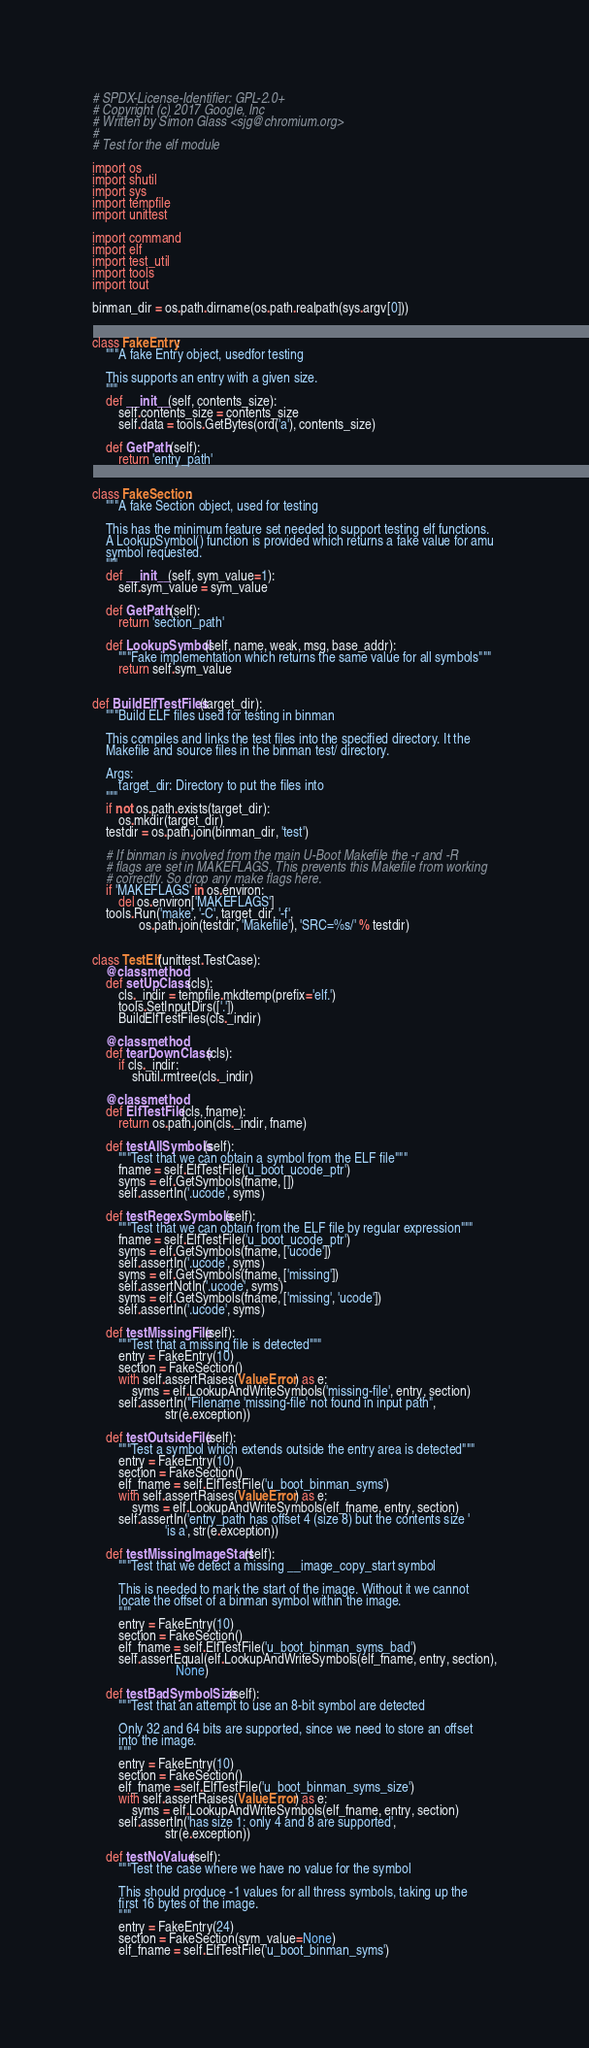Convert code to text. <code><loc_0><loc_0><loc_500><loc_500><_Python_># SPDX-License-Identifier: GPL-2.0+
# Copyright (c) 2017 Google, Inc
# Written by Simon Glass <sjg@chromium.org>
#
# Test for the elf module

import os
import shutil
import sys
import tempfile
import unittest

import command
import elf
import test_util
import tools
import tout

binman_dir = os.path.dirname(os.path.realpath(sys.argv[0]))


class FakeEntry:
    """A fake Entry object, usedfor testing

    This supports an entry with a given size.
    """
    def __init__(self, contents_size):
        self.contents_size = contents_size
        self.data = tools.GetBytes(ord('a'), contents_size)

    def GetPath(self):
        return 'entry_path'


class FakeSection:
    """A fake Section object, used for testing

    This has the minimum feature set needed to support testing elf functions.
    A LookupSymbol() function is provided which returns a fake value for amu
    symbol requested.
    """
    def __init__(self, sym_value=1):
        self.sym_value = sym_value

    def GetPath(self):
        return 'section_path'

    def LookupSymbol(self, name, weak, msg, base_addr):
        """Fake implementation which returns the same value for all symbols"""
        return self.sym_value


def BuildElfTestFiles(target_dir):
    """Build ELF files used for testing in binman

    This compiles and links the test files into the specified directory. It the
    Makefile and source files in the binman test/ directory.

    Args:
        target_dir: Directory to put the files into
    """
    if not os.path.exists(target_dir):
        os.mkdir(target_dir)
    testdir = os.path.join(binman_dir, 'test')

    # If binman is involved from the main U-Boot Makefile the -r and -R
    # flags are set in MAKEFLAGS. This prevents this Makefile from working
    # correctly. So drop any make flags here.
    if 'MAKEFLAGS' in os.environ:
        del os.environ['MAKEFLAGS']
    tools.Run('make', '-C', target_dir, '-f',
              os.path.join(testdir, 'Makefile'), 'SRC=%s/' % testdir)


class TestElf(unittest.TestCase):
    @classmethod
    def setUpClass(cls):
        cls._indir = tempfile.mkdtemp(prefix='elf.')
        tools.SetInputDirs(['.'])
        BuildElfTestFiles(cls._indir)

    @classmethod
    def tearDownClass(cls):
        if cls._indir:
            shutil.rmtree(cls._indir)

    @classmethod
    def ElfTestFile(cls, fname):
        return os.path.join(cls._indir, fname)

    def testAllSymbols(self):
        """Test that we can obtain a symbol from the ELF file"""
        fname = self.ElfTestFile('u_boot_ucode_ptr')
        syms = elf.GetSymbols(fname, [])
        self.assertIn('.ucode', syms)

    def testRegexSymbols(self):
        """Test that we can obtain from the ELF file by regular expression"""
        fname = self.ElfTestFile('u_boot_ucode_ptr')
        syms = elf.GetSymbols(fname, ['ucode'])
        self.assertIn('.ucode', syms)
        syms = elf.GetSymbols(fname, ['missing'])
        self.assertNotIn('.ucode', syms)
        syms = elf.GetSymbols(fname, ['missing', 'ucode'])
        self.assertIn('.ucode', syms)

    def testMissingFile(self):
        """Test that a missing file is detected"""
        entry = FakeEntry(10)
        section = FakeSection()
        with self.assertRaises(ValueError) as e:
            syms = elf.LookupAndWriteSymbols('missing-file', entry, section)
        self.assertIn("Filename 'missing-file' not found in input path",
                      str(e.exception))

    def testOutsideFile(self):
        """Test a symbol which extends outside the entry area is detected"""
        entry = FakeEntry(10)
        section = FakeSection()
        elf_fname = self.ElfTestFile('u_boot_binman_syms')
        with self.assertRaises(ValueError) as e:
            syms = elf.LookupAndWriteSymbols(elf_fname, entry, section)
        self.assertIn('entry_path has offset 4 (size 8) but the contents size '
                      'is a', str(e.exception))

    def testMissingImageStart(self):
        """Test that we detect a missing __image_copy_start symbol

        This is needed to mark the start of the image. Without it we cannot
        locate the offset of a binman symbol within the image.
        """
        entry = FakeEntry(10)
        section = FakeSection()
        elf_fname = self.ElfTestFile('u_boot_binman_syms_bad')
        self.assertEqual(elf.LookupAndWriteSymbols(elf_fname, entry, section),
                         None)

    def testBadSymbolSize(self):
        """Test that an attempt to use an 8-bit symbol are detected

        Only 32 and 64 bits are supported, since we need to store an offset
        into the image.
        """
        entry = FakeEntry(10)
        section = FakeSection()
        elf_fname =self.ElfTestFile('u_boot_binman_syms_size')
        with self.assertRaises(ValueError) as e:
            syms = elf.LookupAndWriteSymbols(elf_fname, entry, section)
        self.assertIn('has size 1: only 4 and 8 are supported',
                      str(e.exception))

    def testNoValue(self):
        """Test the case where we have no value for the symbol

        This should produce -1 values for all thress symbols, taking up the
        first 16 bytes of the image.
        """
        entry = FakeEntry(24)
        section = FakeSection(sym_value=None)
        elf_fname = self.ElfTestFile('u_boot_binman_syms')</code> 